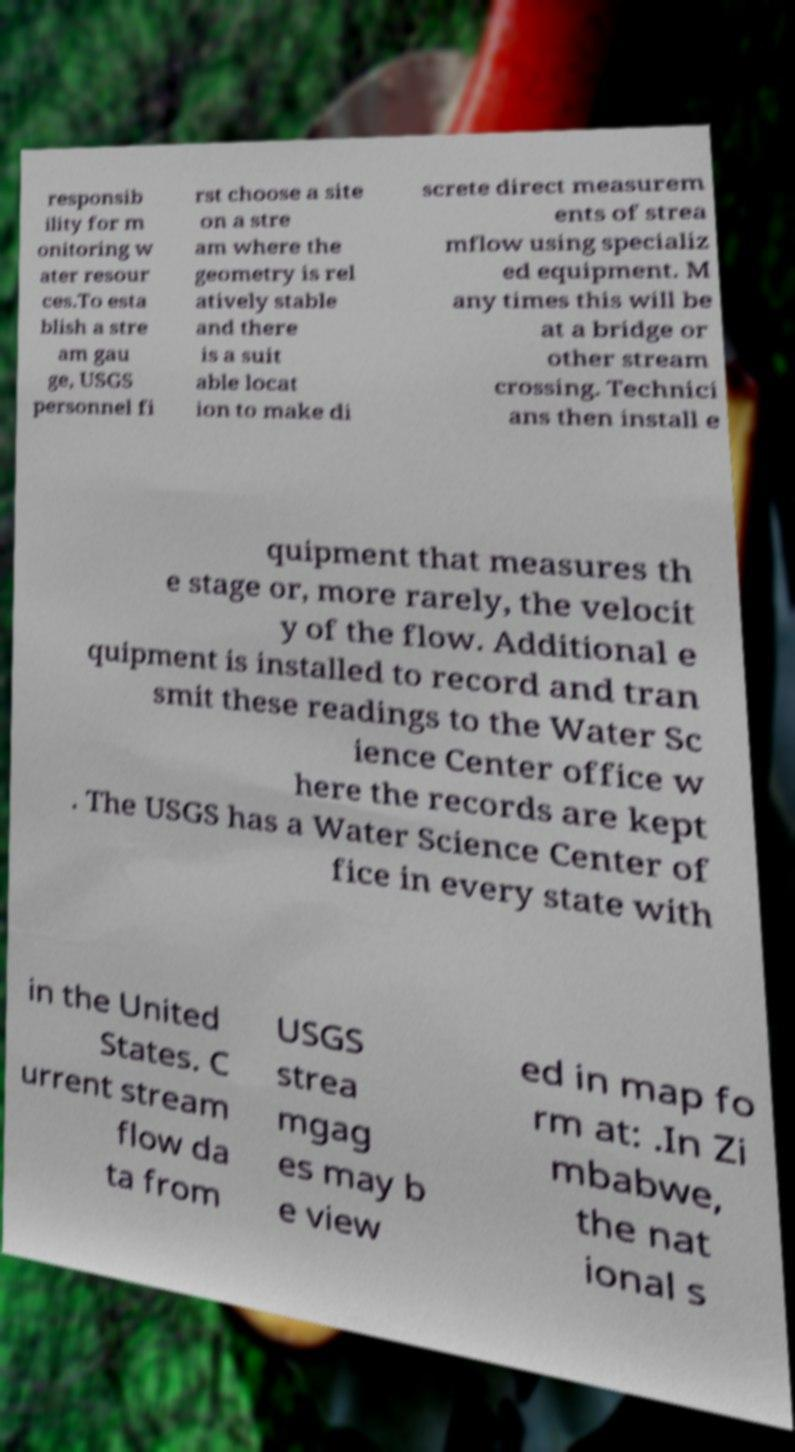I need the written content from this picture converted into text. Can you do that? responsib ility for m onitoring w ater resour ces.To esta blish a stre am gau ge, USGS personnel fi rst choose a site on a stre am where the geometry is rel atively stable and there is a suit able locat ion to make di screte direct measurem ents of strea mflow using specializ ed equipment. M any times this will be at a bridge or other stream crossing. Technici ans then install e quipment that measures th e stage or, more rarely, the velocit y of the flow. Additional e quipment is installed to record and tran smit these readings to the Water Sc ience Center office w here the records are kept . The USGS has a Water Science Center of fice in every state with in the United States. C urrent stream flow da ta from USGS strea mgag es may b e view ed in map fo rm at: .In Zi mbabwe, the nat ional s 